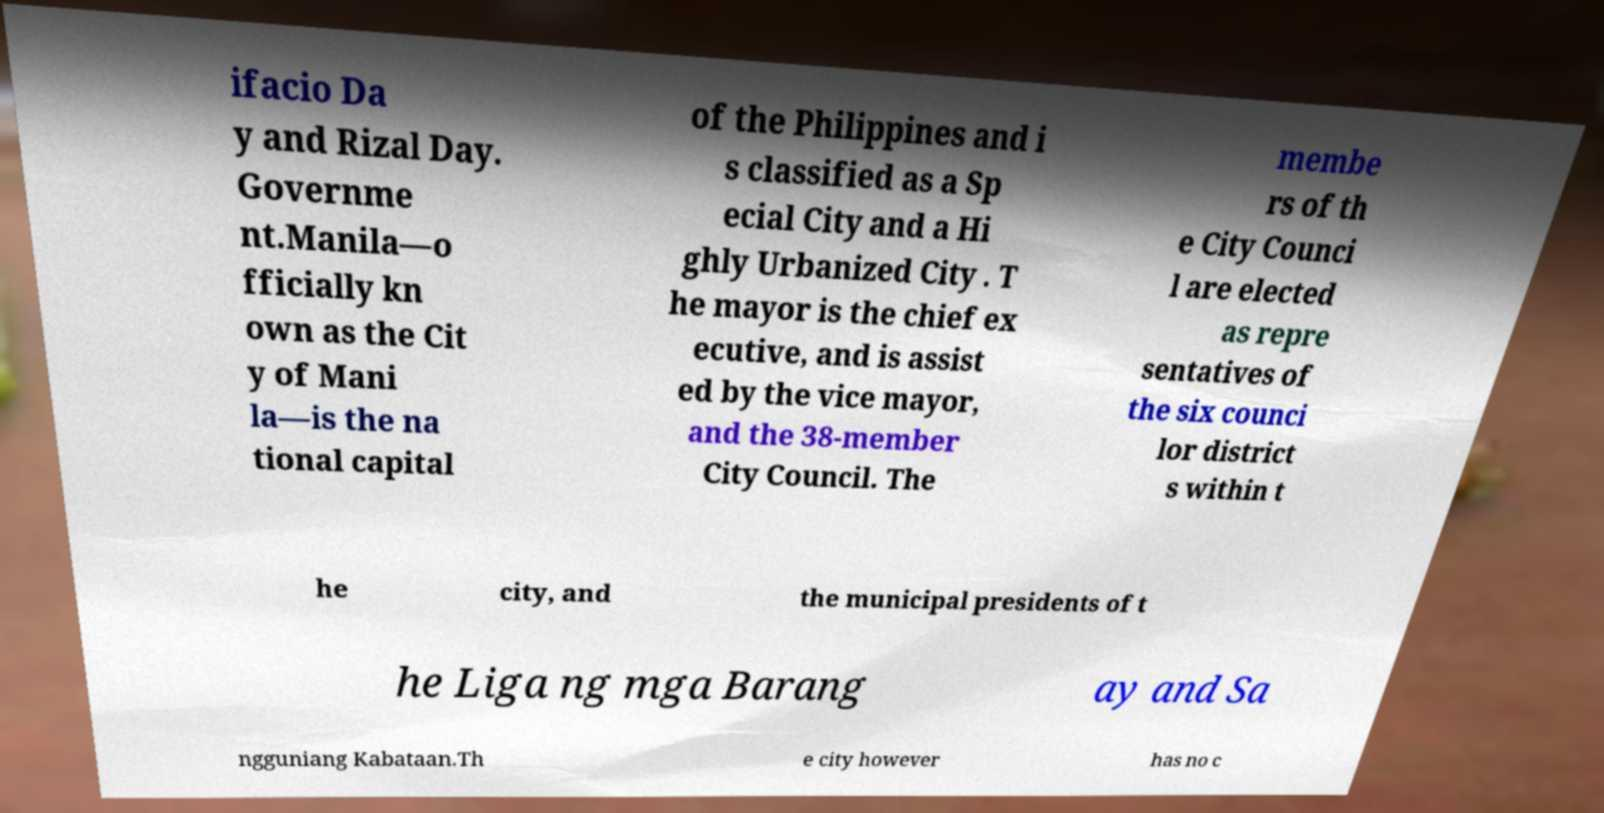Please identify and transcribe the text found in this image. ifacio Da y and Rizal Day. Governme nt.Manila—o fficially kn own as the Cit y of Mani la—is the na tional capital of the Philippines and i s classified as a Sp ecial City and a Hi ghly Urbanized City . T he mayor is the chief ex ecutive, and is assist ed by the vice mayor, and the 38-member City Council. The membe rs of th e City Counci l are elected as repre sentatives of the six counci lor district s within t he city, and the municipal presidents of t he Liga ng mga Barang ay and Sa ngguniang Kabataan.Th e city however has no c 